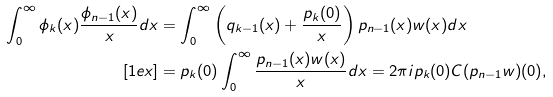<formula> <loc_0><loc_0><loc_500><loc_500>\int _ { 0 } ^ { \infty } \phi _ { k } ( x ) \frac { \phi _ { n - 1 } ( x ) } { x } d x & = \int _ { 0 } ^ { \infty } \left ( q _ { k - 1 } ( x ) + \frac { p _ { k } ( 0 ) } { x } \right ) p _ { n - 1 } ( x ) w ( x ) d x \\ [ 1 e x ] & = p _ { k } ( 0 ) \int _ { 0 } ^ { \infty } \frac { p _ { n - 1 } ( x ) w ( x ) } { x } d x = 2 \pi i p _ { k } ( 0 ) C ( p _ { n - 1 } w ) ( 0 ) ,</formula> 